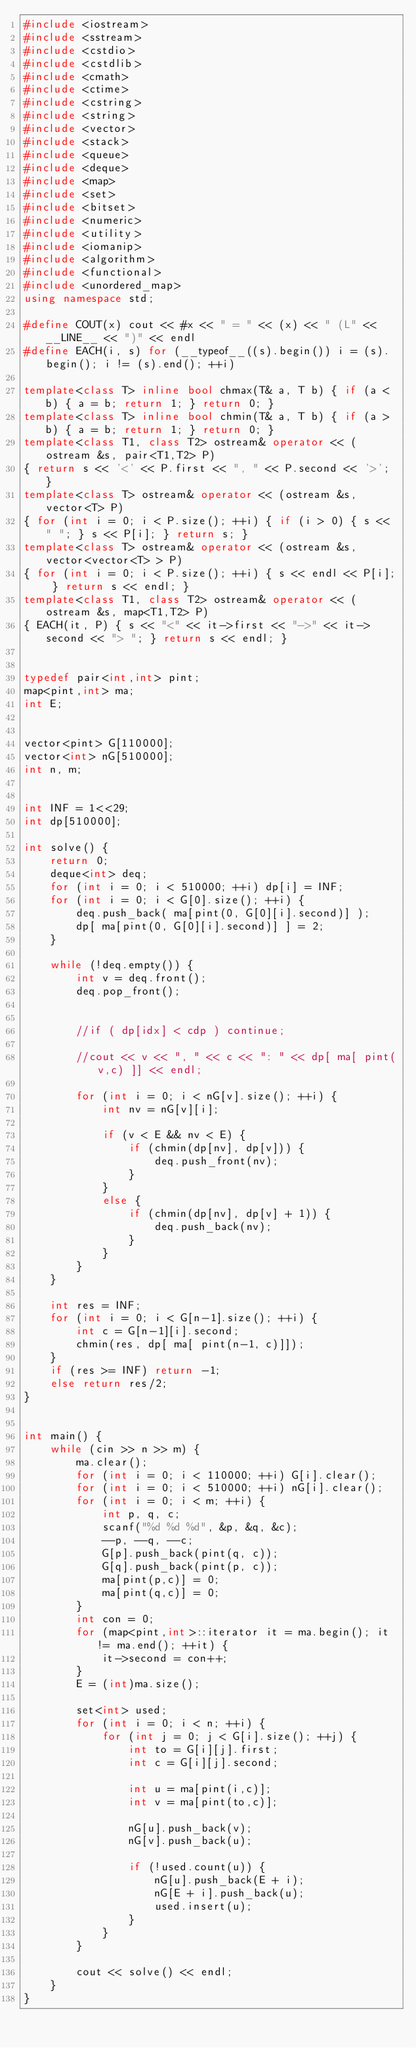Convert code to text. <code><loc_0><loc_0><loc_500><loc_500><_C++_>#include <iostream>
#include <sstream>
#include <cstdio>
#include <cstdlib>
#include <cmath>
#include <ctime>
#include <cstring>
#include <string>
#include <vector>
#include <stack>
#include <queue>
#include <deque>
#include <map>
#include <set>
#include <bitset>
#include <numeric>
#include <utility>
#include <iomanip>
#include <algorithm>
#include <functional>
#include <unordered_map>
using namespace std;

#define COUT(x) cout << #x << " = " << (x) << " (L" << __LINE__ << ")" << endl
#define EACH(i, s) for (__typeof__((s).begin()) i = (s).begin(); i != (s).end(); ++i)

template<class T> inline bool chmax(T& a, T b) { if (a < b) { a = b; return 1; } return 0; }
template<class T> inline bool chmin(T& a, T b) { if (a > b) { a = b; return 1; } return 0; }
template<class T1, class T2> ostream& operator << (ostream &s, pair<T1,T2> P)
{ return s << '<' << P.first << ", " << P.second << '>'; }
template<class T> ostream& operator << (ostream &s, vector<T> P)
{ for (int i = 0; i < P.size(); ++i) { if (i > 0) { s << " "; } s << P[i]; } return s; }
template<class T> ostream& operator << (ostream &s, vector<vector<T> > P)
{ for (int i = 0; i < P.size(); ++i) { s << endl << P[i]; } return s << endl; }
template<class T1, class T2> ostream& operator << (ostream &s, map<T1,T2> P)
{ EACH(it, P) { s << "<" << it->first << "->" << it->second << "> "; } return s << endl; }


typedef pair<int,int> pint;
map<pint,int> ma;
int E;


vector<pint> G[110000];
vector<int> nG[510000];
int n, m;


int INF = 1<<29;
int dp[510000];

int solve() {
    return 0;
    deque<int> deq;
    for (int i = 0; i < 510000; ++i) dp[i] = INF;
    for (int i = 0; i < G[0].size(); ++i) {
        deq.push_back( ma[pint(0, G[0][i].second)] );
        dp[ ma[pint(0, G[0][i].second)] ] = 2;
    }
    
    while (!deq.empty()) {
        int v = deq.front();
        deq.pop_front();

        
        //if ( dp[idx] < cdp ) continue;
        
        //cout << v << ", " << c << ": " << dp[ ma[ pint(v,c) ]] << endl;
        
        for (int i = 0; i < nG[v].size(); ++i) {
            int nv = nG[v][i];
            
            if (v < E && nv < E) {
                if (chmin(dp[nv], dp[v])) {
                    deq.push_front(nv);
                }
            }
            else {
                if (chmin(dp[nv], dp[v] + 1)) {
                    deq.push_back(nv);
                }
            }
        }
    }
    
    int res = INF;
    for (int i = 0; i < G[n-1].size(); ++i) {
        int c = G[n-1][i].second;
        chmin(res, dp[ ma[ pint(n-1, c)]]);
    }
    if (res >= INF) return -1;
    else return res/2;
}


int main() {
    while (cin >> n >> m) {
        ma.clear();
        for (int i = 0; i < 110000; ++i) G[i].clear();
        for (int i = 0; i < 510000; ++i) nG[i].clear();
        for (int i = 0; i < m; ++i) {
            int p, q, c;
            scanf("%d %d %d", &p, &q, &c);
            --p, --q, --c;
            G[p].push_back(pint(q, c));
            G[q].push_back(pint(p, c));
            ma[pint(p,c)] = 0;
            ma[pint(q,c)] = 0;
        }
        int con = 0;
        for (map<pint,int>::iterator it = ma.begin(); it != ma.end(); ++it) {
            it->second = con++;
        }
        E = (int)ma.size();
        
        set<int> used;
        for (int i = 0; i < n; ++i) {
            for (int j = 0; j < G[i].size(); ++j) {
                int to = G[i][j].first;
                int c = G[i][j].second;
                
                int u = ma[pint(i,c)];
                int v = ma[pint(to,c)];
                
                nG[u].push_back(v);
                nG[v].push_back(u);
                
                if (!used.count(u)) {
                    nG[u].push_back(E + i);
                    nG[E + i].push_back(u);
                    used.insert(u);
                }
            }
        }
        
        cout << solve() << endl;
    }
}
















</code> 